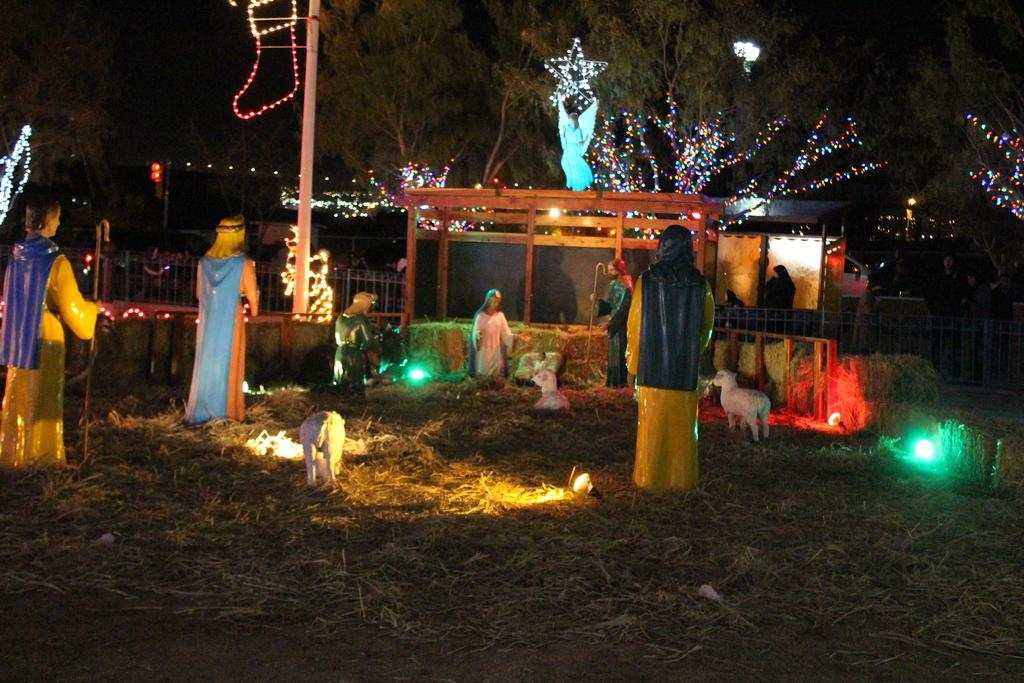What can be seen on the grass in the image? There are statues on the grass in the image. What type of barrier is present in the image? There is fencing from left to right in the image. What is illuminating the trees in the image? There are lights on the trees in the image. Are there any fairies visible among the statues in the image? There is no mention of fairies in the image, only statues. Can you see any chairs in the image? There is no mention of chairs in the image. 